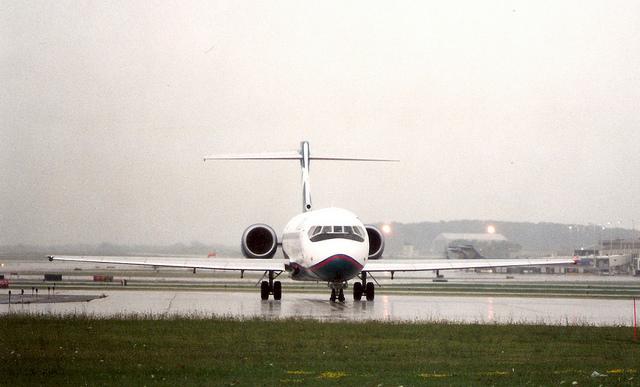Is this a military airplane?
Answer briefly. No. How many propellers on the plane?
Keep it brief. 0. Has it been raining in this image?
Keep it brief. Yes. 